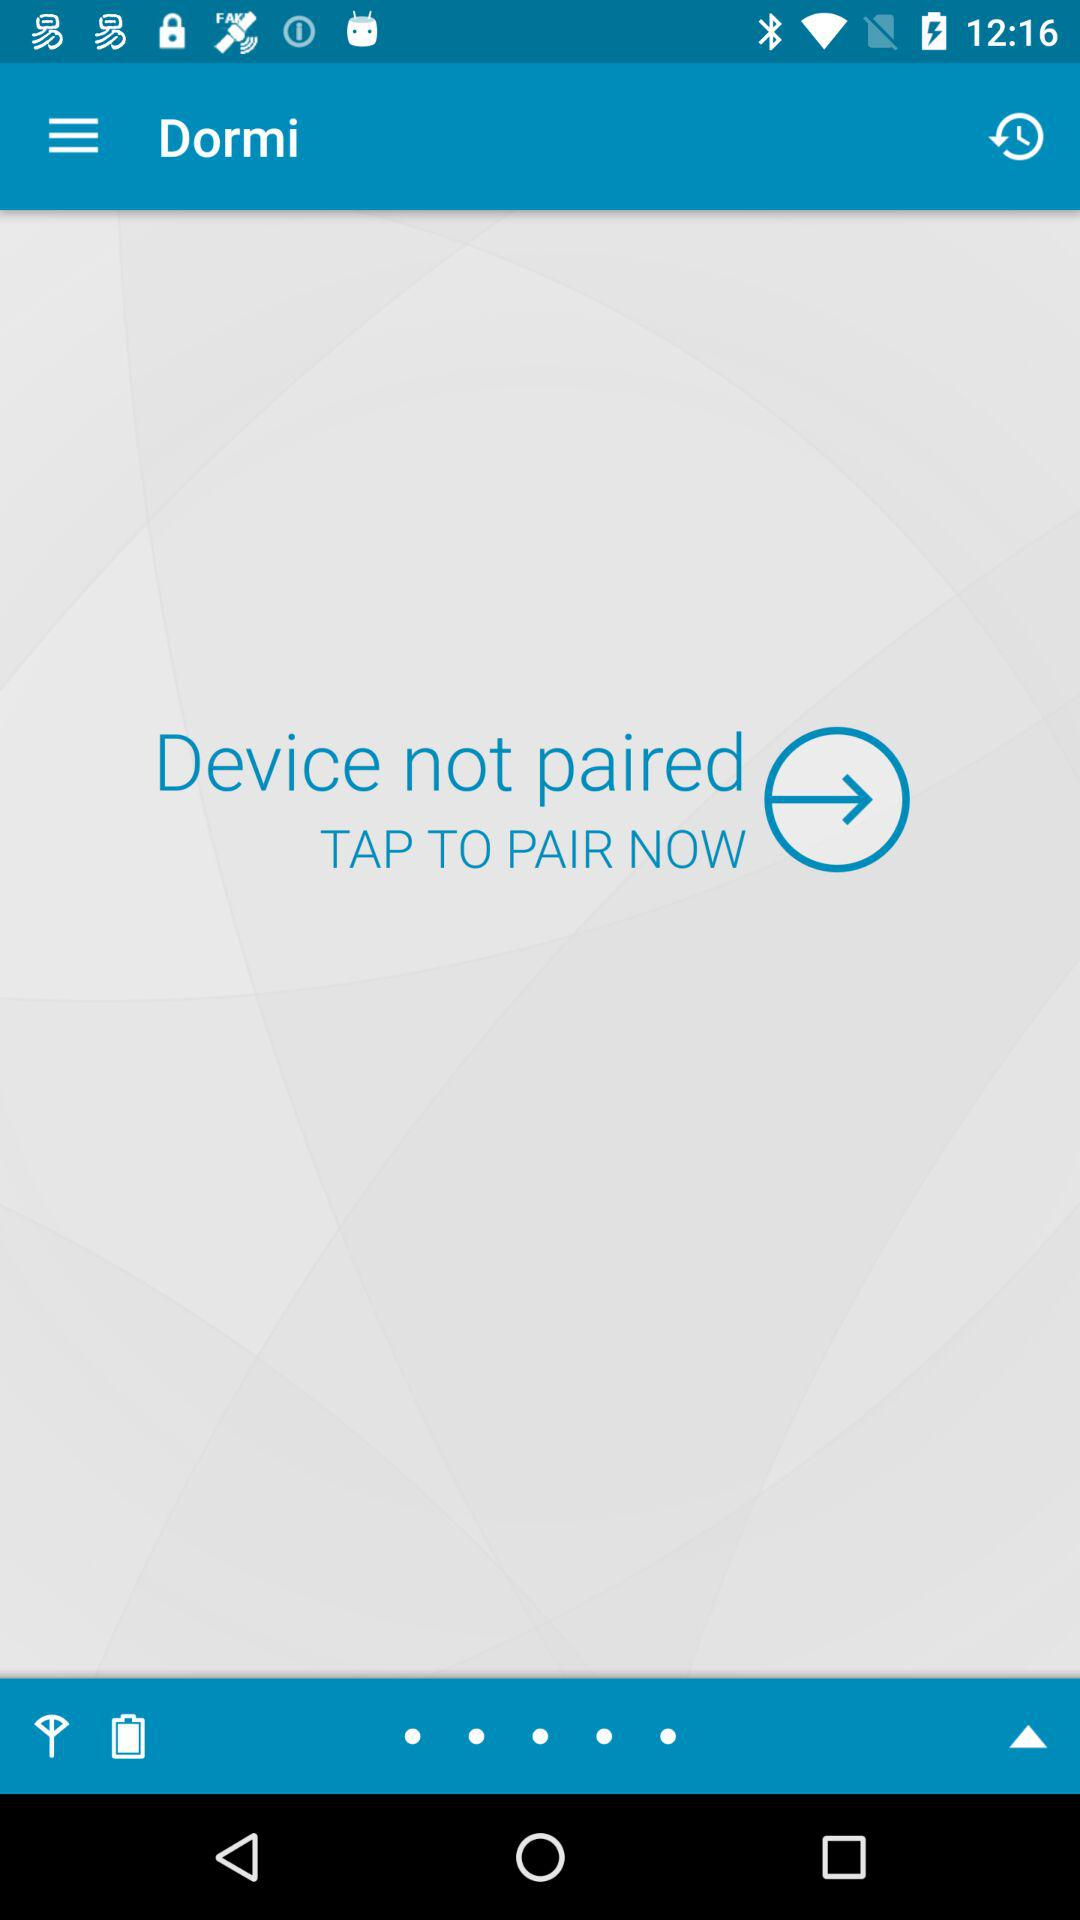What is the application name? The application name is "Dormi". 